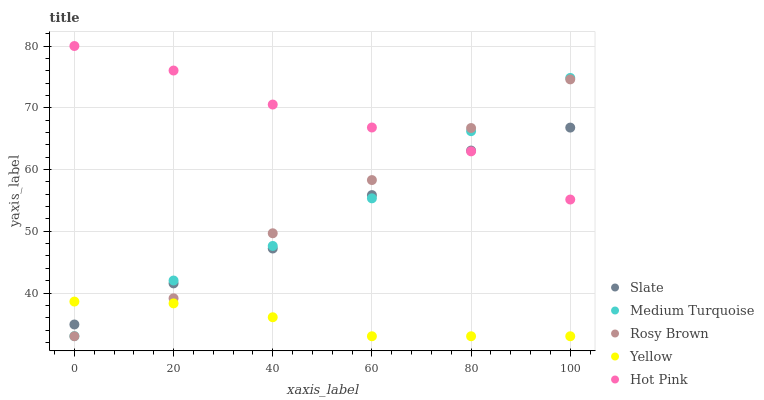Does Yellow have the minimum area under the curve?
Answer yes or no. Yes. Does Hot Pink have the maximum area under the curve?
Answer yes or no. Yes. Does Rosy Brown have the minimum area under the curve?
Answer yes or no. No. Does Rosy Brown have the maximum area under the curve?
Answer yes or no. No. Is Yellow the smoothest?
Answer yes or no. Yes. Is Medium Turquoise the roughest?
Answer yes or no. Yes. Is Rosy Brown the smoothest?
Answer yes or no. No. Is Rosy Brown the roughest?
Answer yes or no. No. Does Rosy Brown have the lowest value?
Answer yes or no. Yes. Does Medium Turquoise have the lowest value?
Answer yes or no. No. Does Hot Pink have the highest value?
Answer yes or no. Yes. Does Rosy Brown have the highest value?
Answer yes or no. No. Is Yellow less than Hot Pink?
Answer yes or no. Yes. Is Hot Pink greater than Yellow?
Answer yes or no. Yes. Does Hot Pink intersect Slate?
Answer yes or no. Yes. Is Hot Pink less than Slate?
Answer yes or no. No. Is Hot Pink greater than Slate?
Answer yes or no. No. Does Yellow intersect Hot Pink?
Answer yes or no. No. 